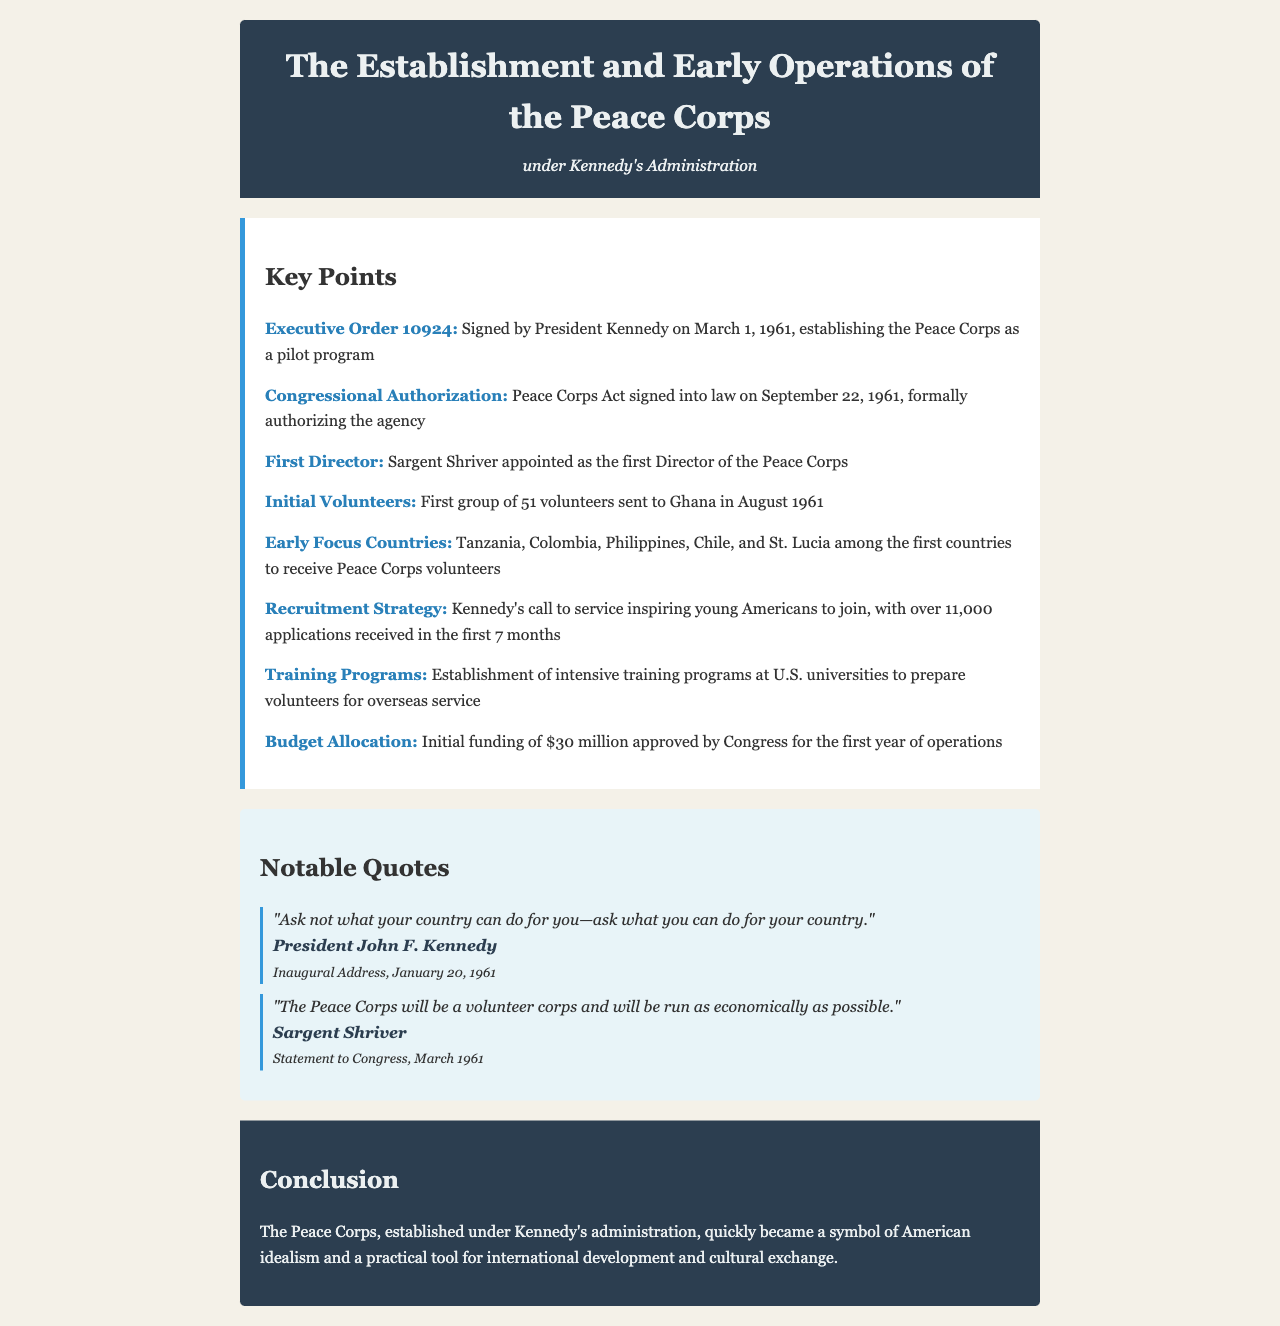What was the date when the Peace Corps Act was signed into law? The Peace Corps Act was signed into law on September 22, 1961.
Answer: September 22, 1961 Who was appointed as the first Director of the Peace Corps? The first Director of the Peace Corps was Sargent Shriver.
Answer: Sargent Shriver How many volunteers were initially sent to Ghana? The first group of volunteers sent to Ghana consisted of 51 individuals.
Answer: 51 What was the initial budget allocation approved by Congress for the first year? The initial funding approved by Congress for the first year of operations was $30 million.
Answer: $30 million Which quote reflects Kennedy's call to public service? The quote "Ask not what your country can do for you—ask what you can do for your country." reflects Kennedy's call to public service.
Answer: "Ask not what your country can do for you—ask what you can do for your country." What countries were among the first to receive Peace Corps volunteers? Among the first countries to receive Peace Corps volunteers were Tanzania, Colombia, Philippines, Chile, and St. Lucia.
Answer: Tanzania, Colombia, Philippines, Chile, and St. Lucia What recruitment strategy did Kennedy utilize for the Peace Corps? Kennedy's recruitment strategy involved his call to service, which inspired young Americans, culminating in over 11,000 applications in the first 7 months.
Answer: Kennedy's call to service What kind of training programs were established for volunteers? Intensive training programs at U.S. universities were established to prepare volunteers for overseas service.
Answer: Intensive training programs at U.S. universities 